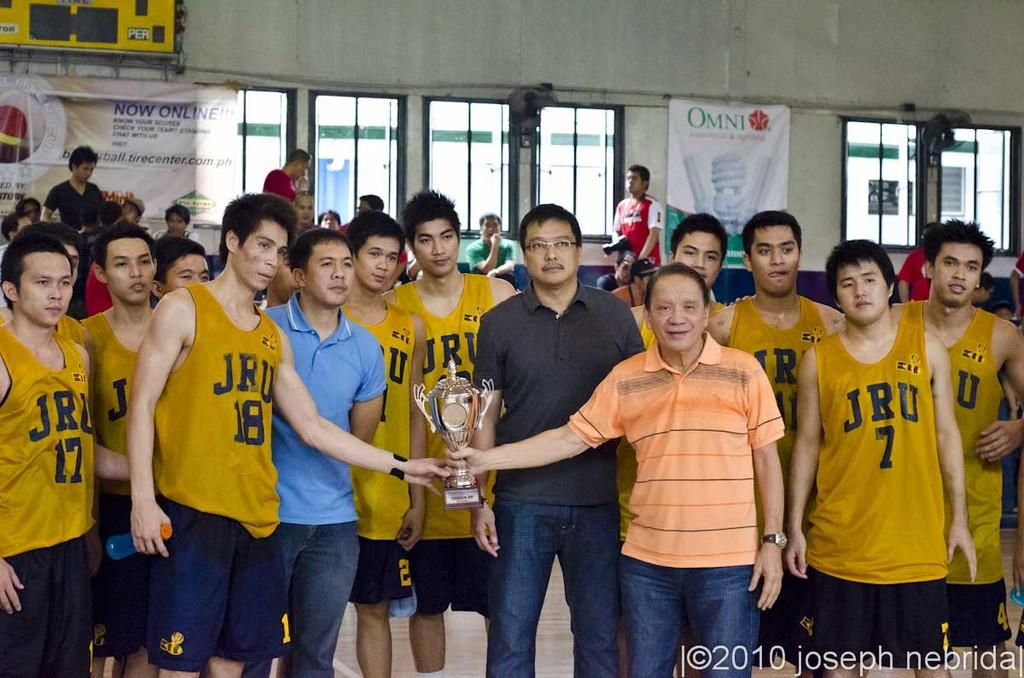<image>
Create a compact narrative representing the image presented. The JRU team holds a trophy they won. 